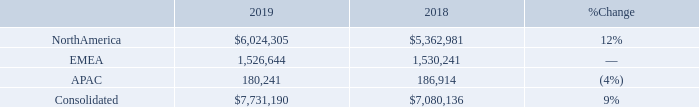2019 Compared to 2018
Net Sales. Net sales increased 9%, or $651 million, in 2019 compared to 2018. Net sales of products (hardware and software) increased 8% and net sales of services increased 20% in 2019 compared to 2018. Our net sales by operating segment for 2019 and 2018 were as follows (dollars in thousands):
How much did the Net sales increased in 2019 compared to 2018? $651 million. How much did Net sales of products (hardware and software) increased in 2019 compared to 2018? 8%. How much did net sales of services increased in 2019 compared to 2018? 20%. What is the change in Net sales of North America between 2018 and 2019?
Answer scale should be: thousand. 6,024,305-5,362,981
Answer: 661324. What is the change in Net Sales of EMEA between 2018 and 2019?
Answer scale should be: thousand. 1,526,644-1,530,241
Answer: -3597. What is the average Net sales of North America for 2018 and 2019?
Answer scale should be: thousand. (6,024,305+5,362,981) / 2
Answer: 5693643. 